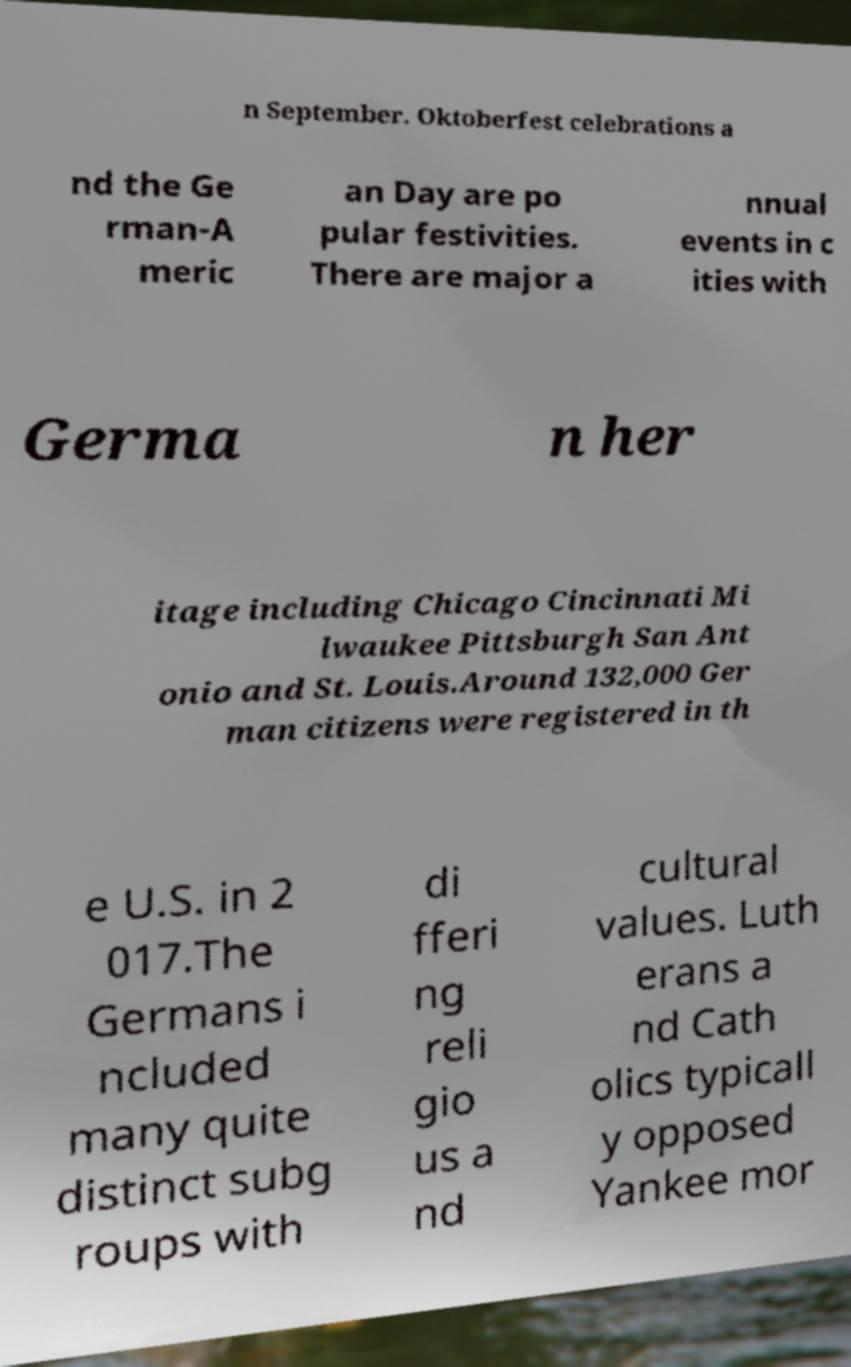For documentation purposes, I need the text within this image transcribed. Could you provide that? n September. Oktoberfest celebrations a nd the Ge rman-A meric an Day are po pular festivities. There are major a nnual events in c ities with Germa n her itage including Chicago Cincinnati Mi lwaukee Pittsburgh San Ant onio and St. Louis.Around 132,000 Ger man citizens were registered in th e U.S. in 2 017.The Germans i ncluded many quite distinct subg roups with di fferi ng reli gio us a nd cultural values. Luth erans a nd Cath olics typicall y opposed Yankee mor 